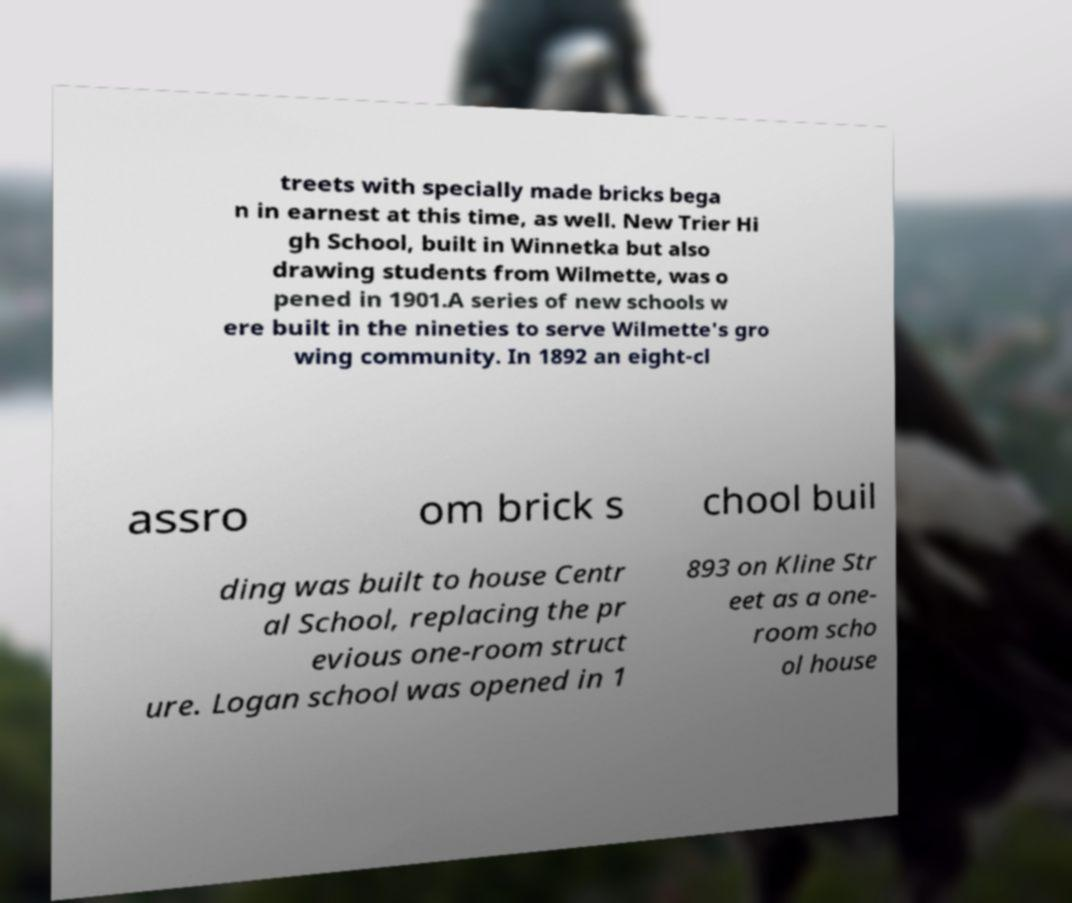There's text embedded in this image that I need extracted. Can you transcribe it verbatim? treets with specially made bricks bega n in earnest at this time, as well. New Trier Hi gh School, built in Winnetka but also drawing students from Wilmette, was o pened in 1901.A series of new schools w ere built in the nineties to serve Wilmette's gro wing community. In 1892 an eight-cl assro om brick s chool buil ding was built to house Centr al School, replacing the pr evious one-room struct ure. Logan school was opened in 1 893 on Kline Str eet as a one- room scho ol house 